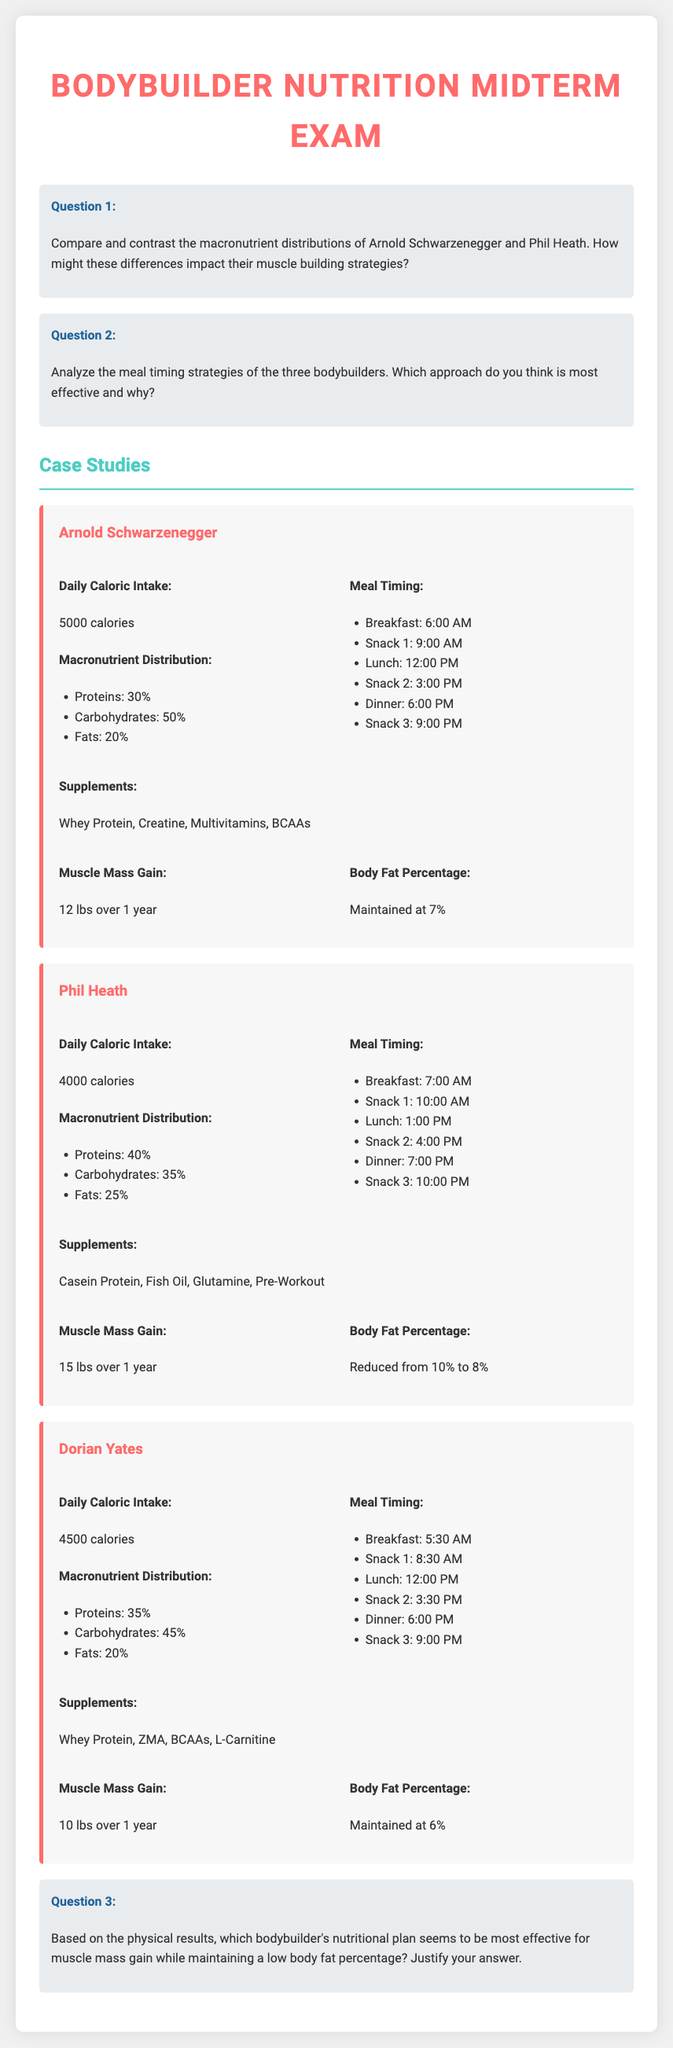What is Arnold Schwarzenegger's daily caloric intake? The document states that Arnold Schwarzenegger has a daily caloric intake of 5000 calories.
Answer: 5000 calories What is Phil Heath's body fat percentage after following his nutrition plan? The document mentions that Phil Heath's body fat percentage reduced from 10% to 8% after his nutrition plan.
Answer: 8% How many pounds of muscle mass did Dorian Yates gain in a year? According to the document, Dorian Yates gained 10 lbs of muscle mass over the course of a year.
Answer: 10 lbs What macronutrient percentage does Phil Heath allocate to proteins? The document indicates that Phil Heath allocates 40% of his macronutrient distribution to proteins.
Answer: 40% Which bodybuilder has the highest daily caloric intake? Based on the information in the document, Arnold Schwarzenegger has the highest daily caloric intake at 5000 calories.
Answer: Arnold Schwarzenegger What meal timing strategy does Arnold Schwarzenegger follow for his dinner? The document lists that Arnold Schwarzenegger has dinner at 6:00 PM.
Answer: 6:00 PM Based on the physical results, who gained the most muscle mass? The document shows that Phil Heath gained the most muscle mass, totaling 15 lbs.
Answer: Phil Heath What type of protein supplement does Dorian Yates use? The document specifies that Dorian Yates uses Whey Protein as part of his supplement regimen.
Answer: Whey Protein 